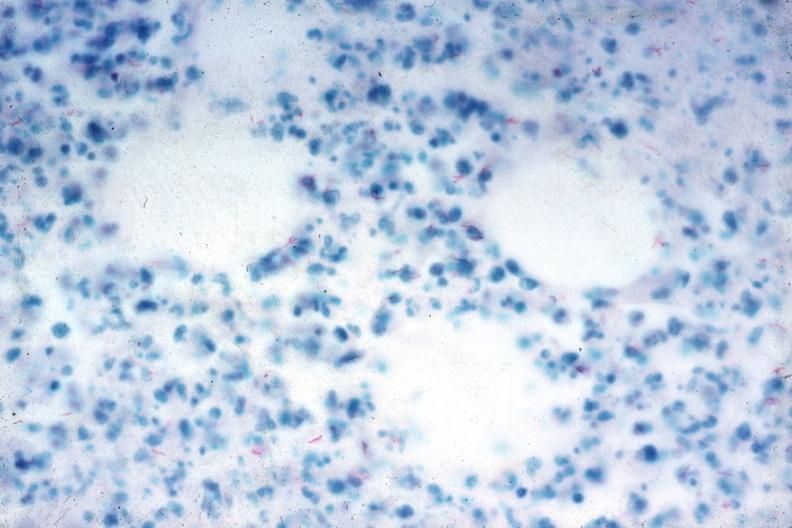what is present?
Answer the question using a single word or phrase. Peritoneum 